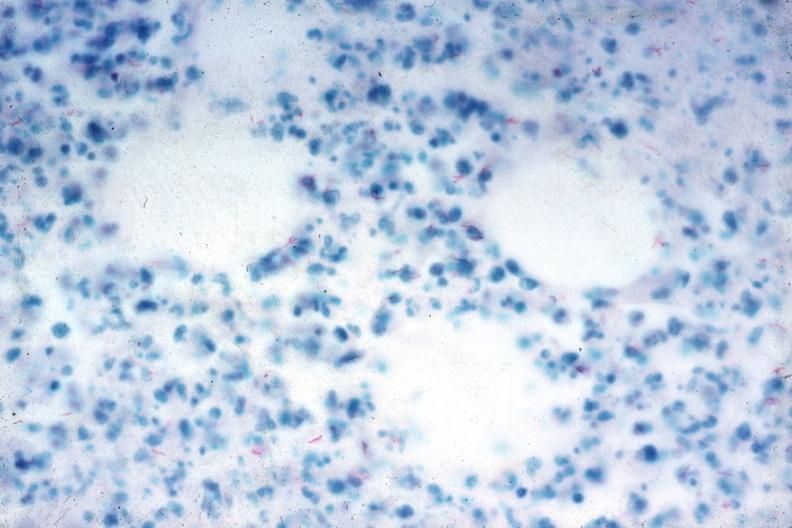what is present?
Answer the question using a single word or phrase. Peritoneum 